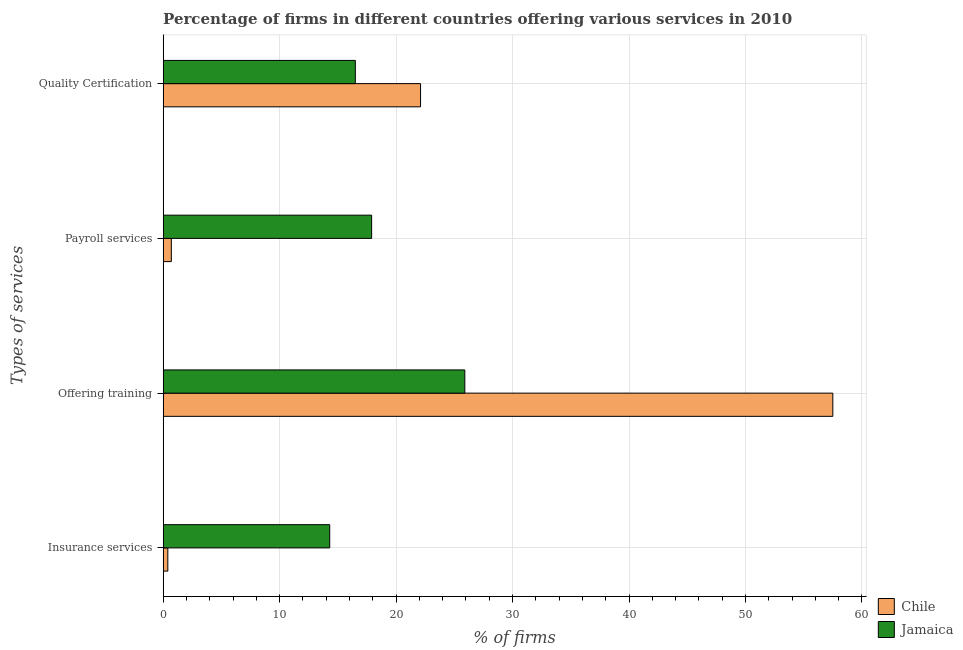How many different coloured bars are there?
Your answer should be compact. 2. How many groups of bars are there?
Provide a succinct answer. 4. How many bars are there on the 2nd tick from the top?
Ensure brevity in your answer.  2. How many bars are there on the 3rd tick from the bottom?
Your answer should be very brief. 2. What is the label of the 2nd group of bars from the top?
Give a very brief answer. Payroll services. Across all countries, what is the maximum percentage of firms offering training?
Keep it short and to the point. 57.5. Across all countries, what is the minimum percentage of firms offering quality certification?
Your answer should be compact. 16.5. In which country was the percentage of firms offering insurance services maximum?
Your response must be concise. Jamaica. What is the total percentage of firms offering training in the graph?
Your answer should be compact. 83.4. What is the difference between the percentage of firms offering payroll services in Chile and that in Jamaica?
Keep it short and to the point. -17.2. What is the difference between the percentage of firms offering insurance services in Jamaica and the percentage of firms offering payroll services in Chile?
Provide a succinct answer. 13.6. What is the average percentage of firms offering quality certification per country?
Offer a terse response. 19.3. What is the difference between the percentage of firms offering payroll services and percentage of firms offering quality certification in Jamaica?
Keep it short and to the point. 1.4. In how many countries, is the percentage of firms offering payroll services greater than 2 %?
Your response must be concise. 1. What is the ratio of the percentage of firms offering payroll services in Jamaica to that in Chile?
Offer a terse response. 25.57. Is the percentage of firms offering quality certification in Jamaica less than that in Chile?
Provide a short and direct response. Yes. Is the difference between the percentage of firms offering quality certification in Chile and Jamaica greater than the difference between the percentage of firms offering insurance services in Chile and Jamaica?
Your answer should be very brief. Yes. What is the difference between the highest and the second highest percentage of firms offering quality certification?
Offer a very short reply. 5.6. What is the difference between the highest and the lowest percentage of firms offering quality certification?
Give a very brief answer. 5.6. Is the sum of the percentage of firms offering payroll services in Jamaica and Chile greater than the maximum percentage of firms offering insurance services across all countries?
Give a very brief answer. Yes. Is it the case that in every country, the sum of the percentage of firms offering insurance services and percentage of firms offering payroll services is greater than the sum of percentage of firms offering quality certification and percentage of firms offering training?
Make the answer very short. No. How many bars are there?
Provide a short and direct response. 8. How many legend labels are there?
Your answer should be compact. 2. How are the legend labels stacked?
Your response must be concise. Vertical. What is the title of the graph?
Your answer should be compact. Percentage of firms in different countries offering various services in 2010. Does "Upper middle income" appear as one of the legend labels in the graph?
Your answer should be compact. No. What is the label or title of the X-axis?
Ensure brevity in your answer.  % of firms. What is the label or title of the Y-axis?
Offer a terse response. Types of services. What is the % of firms in Jamaica in Insurance services?
Your answer should be compact. 14.3. What is the % of firms in Chile in Offering training?
Your answer should be very brief. 57.5. What is the % of firms of Jamaica in Offering training?
Offer a very short reply. 25.9. What is the % of firms of Chile in Quality Certification?
Offer a terse response. 22.1. Across all Types of services, what is the maximum % of firms in Chile?
Provide a succinct answer. 57.5. Across all Types of services, what is the maximum % of firms of Jamaica?
Keep it short and to the point. 25.9. What is the total % of firms of Chile in the graph?
Offer a terse response. 80.7. What is the total % of firms of Jamaica in the graph?
Make the answer very short. 74.6. What is the difference between the % of firms in Chile in Insurance services and that in Offering training?
Give a very brief answer. -57.1. What is the difference between the % of firms of Chile in Insurance services and that in Payroll services?
Your answer should be compact. -0.3. What is the difference between the % of firms in Jamaica in Insurance services and that in Payroll services?
Provide a short and direct response. -3.6. What is the difference between the % of firms of Chile in Insurance services and that in Quality Certification?
Your answer should be compact. -21.7. What is the difference between the % of firms of Jamaica in Insurance services and that in Quality Certification?
Offer a terse response. -2.2. What is the difference between the % of firms of Chile in Offering training and that in Payroll services?
Offer a very short reply. 56.8. What is the difference between the % of firms in Jamaica in Offering training and that in Payroll services?
Your answer should be very brief. 8. What is the difference between the % of firms of Chile in Offering training and that in Quality Certification?
Offer a terse response. 35.4. What is the difference between the % of firms of Chile in Payroll services and that in Quality Certification?
Your response must be concise. -21.4. What is the difference between the % of firms in Chile in Insurance services and the % of firms in Jamaica in Offering training?
Provide a succinct answer. -25.5. What is the difference between the % of firms in Chile in Insurance services and the % of firms in Jamaica in Payroll services?
Ensure brevity in your answer.  -17.5. What is the difference between the % of firms in Chile in Insurance services and the % of firms in Jamaica in Quality Certification?
Provide a succinct answer. -16.1. What is the difference between the % of firms in Chile in Offering training and the % of firms in Jamaica in Payroll services?
Ensure brevity in your answer.  39.6. What is the difference between the % of firms in Chile in Payroll services and the % of firms in Jamaica in Quality Certification?
Your response must be concise. -15.8. What is the average % of firms of Chile per Types of services?
Your answer should be very brief. 20.18. What is the average % of firms in Jamaica per Types of services?
Ensure brevity in your answer.  18.65. What is the difference between the % of firms of Chile and % of firms of Jamaica in Offering training?
Offer a terse response. 31.6. What is the difference between the % of firms of Chile and % of firms of Jamaica in Payroll services?
Provide a short and direct response. -17.2. What is the ratio of the % of firms of Chile in Insurance services to that in Offering training?
Make the answer very short. 0.01. What is the ratio of the % of firms of Jamaica in Insurance services to that in Offering training?
Your answer should be very brief. 0.55. What is the ratio of the % of firms of Chile in Insurance services to that in Payroll services?
Provide a short and direct response. 0.57. What is the ratio of the % of firms in Jamaica in Insurance services to that in Payroll services?
Provide a short and direct response. 0.8. What is the ratio of the % of firms in Chile in Insurance services to that in Quality Certification?
Make the answer very short. 0.02. What is the ratio of the % of firms in Jamaica in Insurance services to that in Quality Certification?
Give a very brief answer. 0.87. What is the ratio of the % of firms of Chile in Offering training to that in Payroll services?
Your response must be concise. 82.14. What is the ratio of the % of firms in Jamaica in Offering training to that in Payroll services?
Provide a succinct answer. 1.45. What is the ratio of the % of firms of Chile in Offering training to that in Quality Certification?
Keep it short and to the point. 2.6. What is the ratio of the % of firms in Jamaica in Offering training to that in Quality Certification?
Offer a very short reply. 1.57. What is the ratio of the % of firms of Chile in Payroll services to that in Quality Certification?
Ensure brevity in your answer.  0.03. What is the ratio of the % of firms in Jamaica in Payroll services to that in Quality Certification?
Keep it short and to the point. 1.08. What is the difference between the highest and the second highest % of firms of Chile?
Offer a very short reply. 35.4. What is the difference between the highest and the lowest % of firms in Chile?
Make the answer very short. 57.1. 